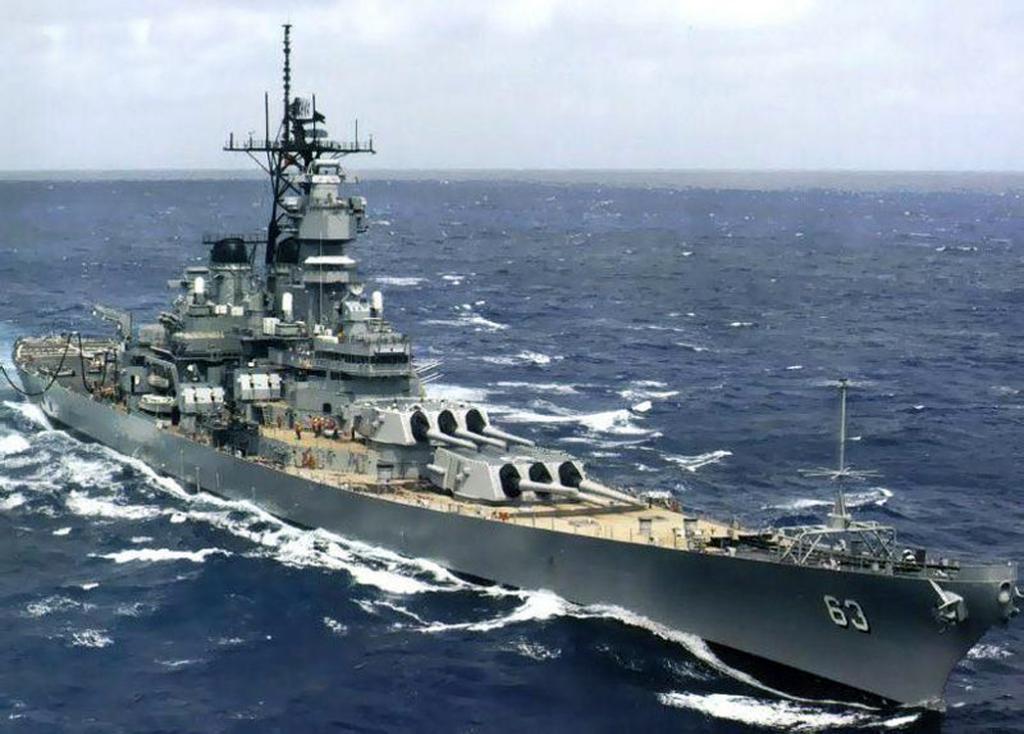Describe this image in one or two sentences. In this image, this looks like a naval ship, which is moving on the water. I think this is the sea. Here is the sky. 